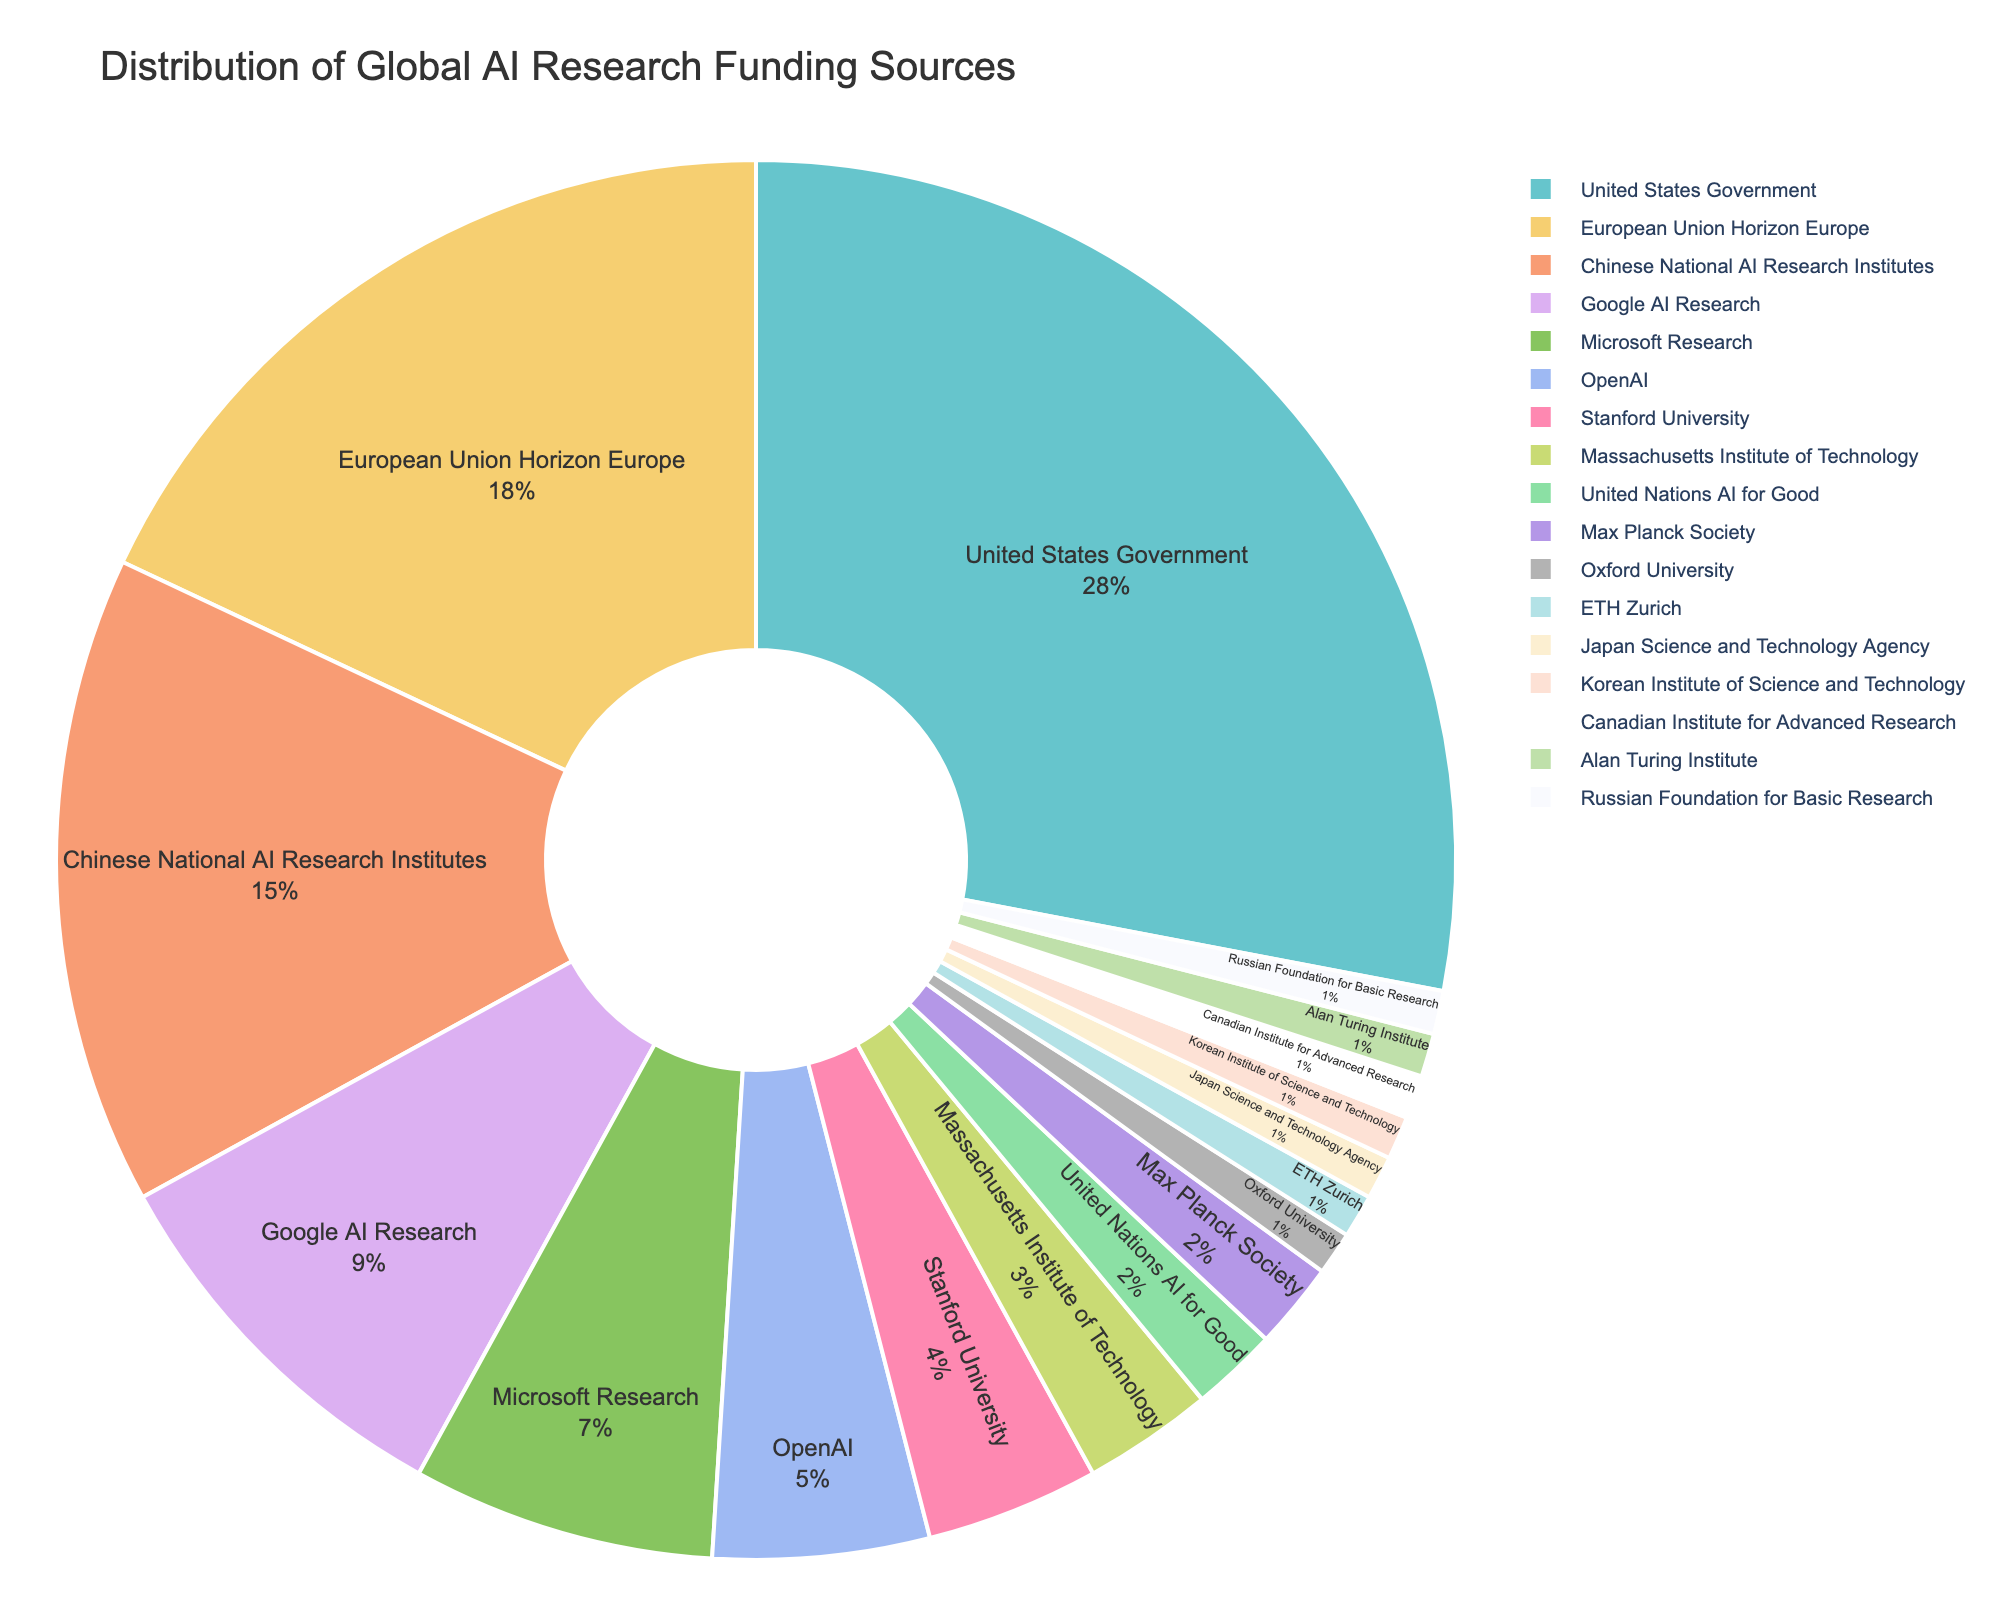Which funding source contributes the highest percentage? The pie chart shows the relative contribution of each funding source. By visually identifying the largest segment of the pie chart and reading its label, we can determine the funding source with the highest contribution.
Answer: United States Government How does the funding from Google AI Research compare to that from Microsoft Research? Locate the segments labeled "Google AI Research" and "Microsoft Research." Compare the percentages shown next to these labels to determine which is higher.
Answer: Google AI Research is greater What is the combined percentage of funding from academia (Stanford University, Massachusetts Institute of Technology, Max Planck Society, Oxford University, ETH Zurich)? To find the combined percentage, sum the percentages of the academic institutions listed: 4% (Stanford University) + 3% (Massachusetts Institute of Technology) + 2% (Max Planck Society) + 1% (Oxford University) + 1% (ETH Zurich).
Answer: 11% Which entity provides more funding: the Chinese National AI Research Institutes or the European Union Horizon Europe program? Identify the segments labeled "Chinese National AI Research Institutes" and "European Union Horizon Europe" and compare their percentages to see which is higher.
Answer: European Union Horizon Europe What is the difference in funding percentage between OpenAI and the United Nations AI for Good? Subtract the percentage of the United Nations AI for Good (2%) from the percentage of OpenAI (5%).
Answer: 3% Identify the smallest contributors and their combined percentage. Find the smallest segments and read their labels and percentages: Oxford University (1%), ETH Zurich (1%), Japan Science and Technology Agency (1%), Korean Institute of Science and Technology (1%), Canadian Institute for Advanced Research (1%), Alan Turing Institute (1%), Russian Foundation for Basic Research (1%). Add these percentages.
Answer: 7% Which has a larger funding share: non-governmental organizations (NGOs) or European national governments (Japanese, Korean, and Russian institutions combined)? Compare the segment for the United Nations AI for Good (2%) with the combined percentage of Japan Science and Technology Agency (1%), Korean Institute of Science and Technology (1%), Russian Foundation for Basic Research (1%) by summing them up: 1% + 1% + 1%. Determine which is larger.
Answer: European national governments combined What is the average percentage of the three largest private sector contributions (Google AI Research, Microsoft Research, OpenAI)? Sum the percentages of Google AI Research, Microsoft Research, and OpenAI and divide by three: (9 + 7 + 5) / 3.
Answer: 7% Which academic institution contributes the least, and what is its funding percentage? Locate the academic institutions labeled on the pie chart and identify the one with the smallest percentage.
Answer: ETH Zurich, 1% 